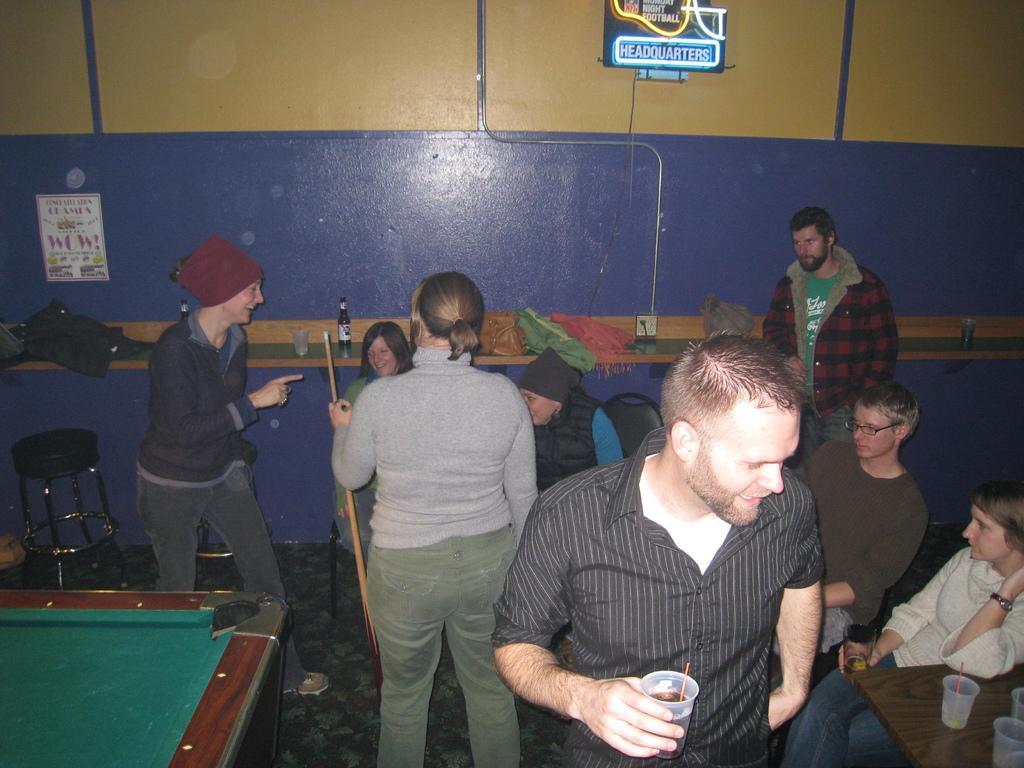How would you summarize this image in a sentence or two? In this image there are group of people. At the back there is a poster on the wall and there is a bottle, glass, bag, clothes on the table. At the left there is a stool. 